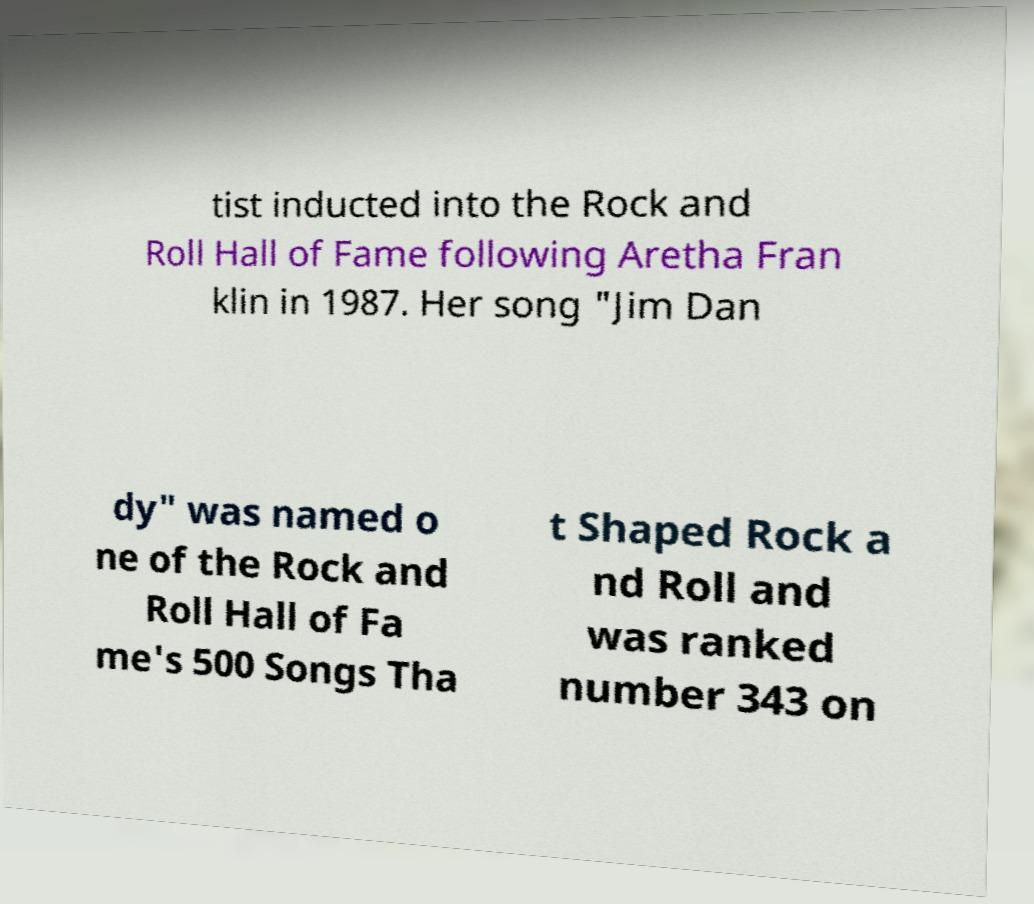Can you accurately transcribe the text from the provided image for me? tist inducted into the Rock and Roll Hall of Fame following Aretha Fran klin in 1987. Her song "Jim Dan dy" was named o ne of the Rock and Roll Hall of Fa me's 500 Songs Tha t Shaped Rock a nd Roll and was ranked number 343 on 